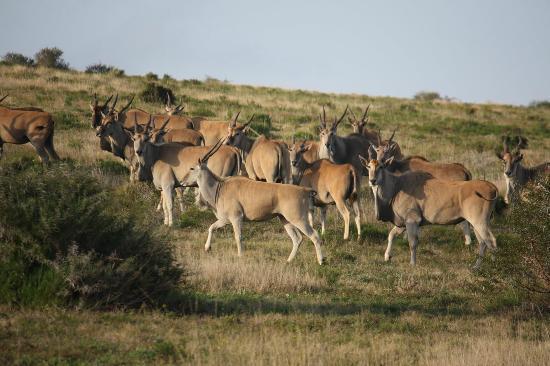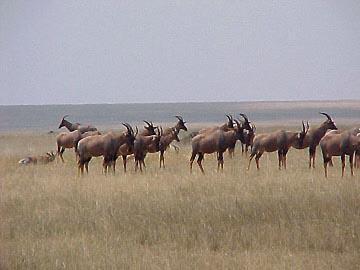The first image is the image on the left, the second image is the image on the right. Examine the images to the left and right. Is the description "Zebras and antelopes are mingling together." accurate? Answer yes or no. No. The first image is the image on the left, the second image is the image on the right. For the images shown, is this caption "There are a number of zebras among the other types of animals present." true? Answer yes or no. No. 